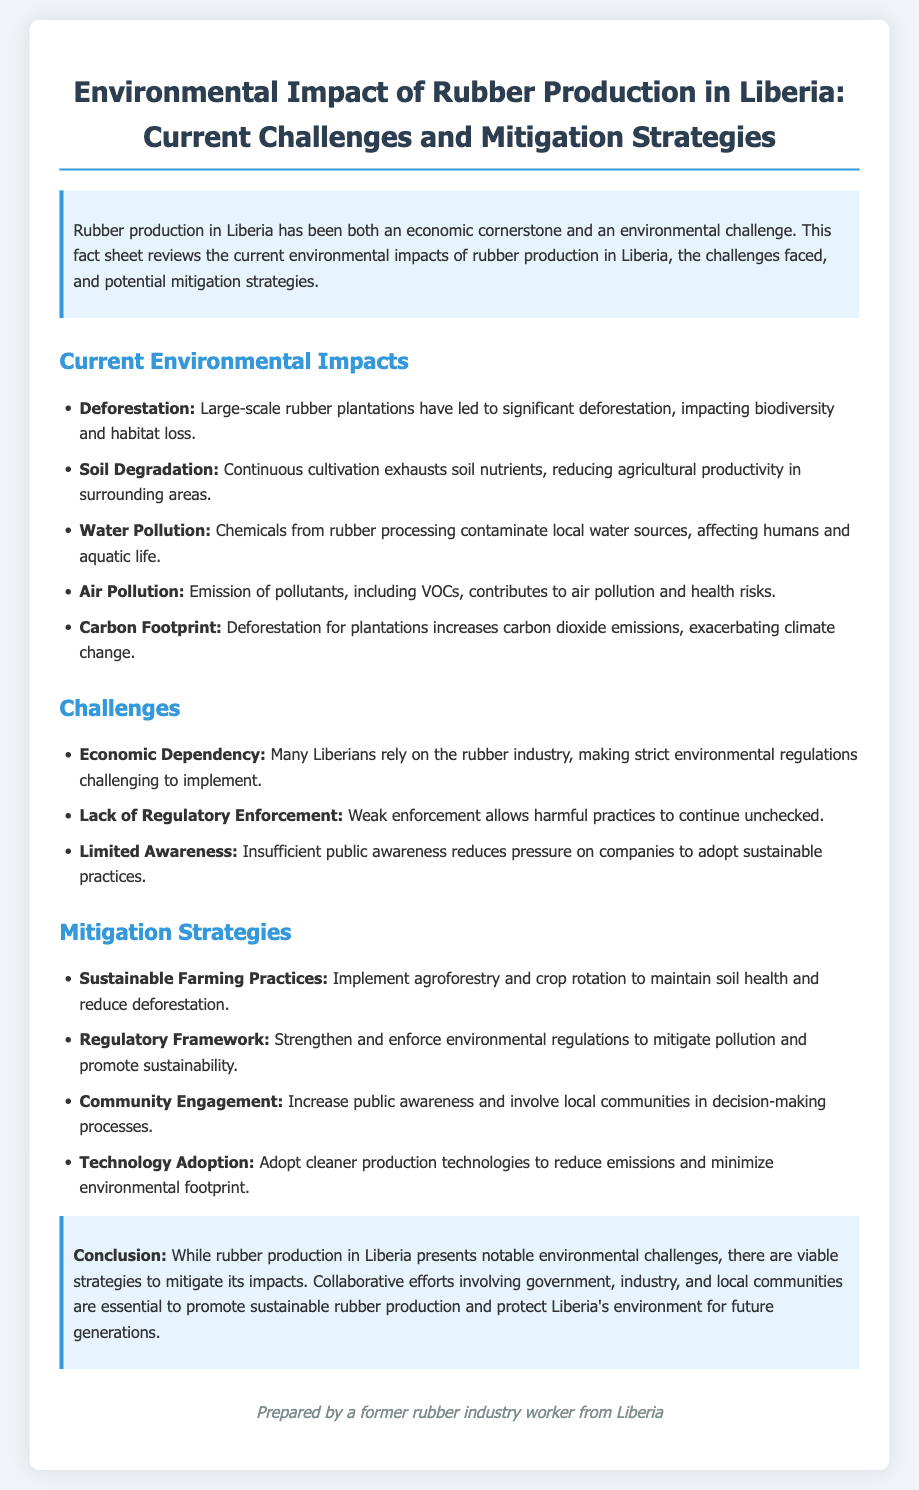What is the main economic role of rubber production in Liberia? The fact sheet states that rubber production has been both an economic cornerstone and an environmental challenge.
Answer: Economic cornerstone What is a significant environmental impact of rubber production listed in the document? The document lists deforestation as one of the key environmental impacts.
Answer: Deforestation How does rubber production contribute to water issues in Liberia? The fact sheet mentions that chemicals from rubber processing contaminate local water sources.
Answer: Water pollution What challenge related to regulation is highlighted in the document? The document notes that weak enforcement allows harmful practices to continue unchecked.
Answer: Lack of Regulatory Enforcement What strategy is suggested to maintain soil health? The document recommends implementing agroforestry and crop rotation for sustainable farming practices.
Answer: Sustainable Farming Practices Which group is emphasized for involvement in decision-making processes? The fact sheet calls for local communities to be involved in decision-making processes.
Answer: Local communities What is one mitigation strategy for reducing emissions? The document suggests adopting cleaner production technologies to minimize environmental footprint.
Answer: Technology Adoption What is the conclusion stated in the fact sheet? The conclusion emphasizes the importance of collaborative efforts for sustainable rubber production.
Answer: Collaborative efforts How many challenges are listed in the document? The document lists three challenges faced by the rubber industry in Liberia.
Answer: Three 